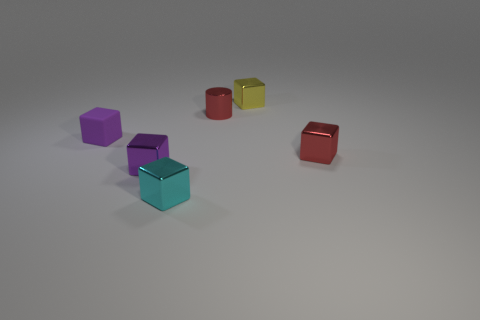Add 3 rubber cubes. How many objects exist? 9 Subtract all small red blocks. How many blocks are left? 4 Subtract all cylinders. How many objects are left? 5 Add 2 small purple shiny objects. How many small purple shiny objects exist? 3 Subtract all yellow cubes. How many cubes are left? 4 Subtract 0 yellow balls. How many objects are left? 6 Subtract 3 blocks. How many blocks are left? 2 Subtract all blue cylinders. Subtract all red spheres. How many cylinders are left? 1 Subtract all gray cylinders. How many gray cubes are left? 0 Subtract all red rubber balls. Subtract all red shiny objects. How many objects are left? 4 